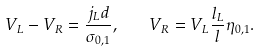Convert formula to latex. <formula><loc_0><loc_0><loc_500><loc_500>V _ { L } - V _ { R } = \frac { j _ { L } d } { \sigma _ { 0 , 1 } } , \quad V _ { R } = V _ { L } \frac { l _ { L } } { l } \eta _ { 0 , 1 } .</formula> 